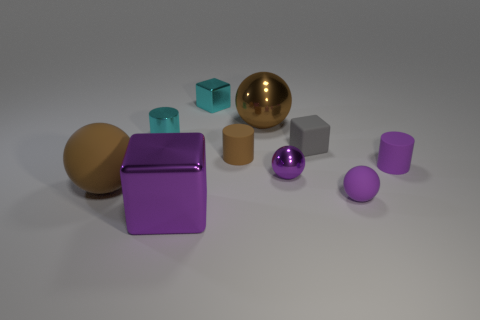Subtract all big purple blocks. How many blocks are left? 2 Subtract all cyan cylinders. How many cylinders are left? 2 Subtract 1 cylinders. How many cylinders are left? 2 Subtract all blocks. How many objects are left? 7 Add 7 big brown matte spheres. How many big brown matte spheres are left? 8 Add 4 small yellow matte blocks. How many small yellow matte blocks exist? 4 Subtract 0 blue spheres. How many objects are left? 10 Subtract all green blocks. Subtract all green spheres. How many blocks are left? 3 Subtract all purple cubes. How many green cylinders are left? 0 Subtract all cyan metal things. Subtract all red things. How many objects are left? 8 